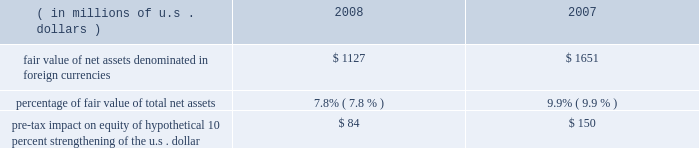Foreign currency exchange rate risk many of our non-u.s .
Companies maintain both assets and liabilities in local currencies .
Therefore , foreign exchange rate risk is generally limited to net assets denominated in those foreign currencies .
Foreign exchange rate risk is reviewed as part of our risk management process .
Locally required capital levels are invested in home currencies in order to satisfy regulatory require- ments and to support local insurance operations regardless of currency fluctuations .
The principal currencies creating foreign exchange risk for us are the british pound sterling , the euro , and the canadian dollar .
The table provides more information on our exposure to foreign exchange rate risk at december 31 , 2008 and 2007. .
Reinsurance of gmdb and gmib guarantees our net income is directly impacted by changes in the reserves calculated in connection with the reinsurance of variable annuity guarantees , primarily gmdb and gmib .
These reserves are calculated in accordance with sop 03-1 ( sop reserves ) and changes in these reserves are reflected as life and annuity benefit expense , which is included in life underwriting income .
In addition , our net income is directly impacted by the change in the fair value of the gmib liability ( fvl ) , which is classified as a derivative according to fas 133 .
The fair value liability established for a gmib reinsurance contract represents the differ- ence between the fair value of the contract and the sop 03-1 reserves .
Changes in the fair value of the gmib liability , net of associated changes in the calculated sop 03-1 reserve , are reflected as realized gains or losses .
Ace views our variable annuity reinsurance business as having a similar risk profile to that of catastrophe reinsurance , with the probability of long-term economic loss relatively small at the time of pricing .
Adverse changes in market factors and policyholder behavior will have an impact on both life underwriting income and net income .
When evaluating these risks , we expect to be compensated for taking both the risk of a cumulative long-term economic net loss , as well as the short-term accounting variations caused by these market movements .
Therefore , we evaluate this business in terms of its long-term eco- nomic risk and reward .
The ultimate risk to the variable annuity guaranty reinsurance business is a long-term underperformance of investment returns , which can be exacerbated by a long-term reduction in interest rates .
Following a market downturn , continued market underperformance over a period of five to seven years would eventually result in a higher level of paid claims as policyholders accessed their guarantees through death or annuitization .
However , if market conditions improved following a downturn , sop 03-1 reserves and fair value liability would fall reflecting a decreased likelihood of future claims , which would result in an increase in both life underwriting income and net income .
As of december 31 , 2008 , management established the sop 03-1 reserve based on the benefit ratio calculated using actual market values at december 31 , 2008 .
Management exercises judgment in determining the extent to which short-term market movements impact the sop 03-1 reserve .
The sop 03-1 reserve is based on the calculation of a long-term benefit ratio ( or loss ratio ) for the variable annuity guarantee reinsurance .
Despite the long-term nature of the risk the benefit ratio calculation is impacted by short-term market movements that may be judged by management to be temporary or transient .
Management will , in keeping with the language in sop 03-1 , regularly examine both quantitative and qualitative analysis and management will determine if , in its judgment , the change in the calculated benefit ratio is of sufficient magnitude and has persisted for a sufficient duration to warrant a change in the benefit ratio used to establish the sop 03-1 reserve .
This has no impact on either premium received or claims paid nor does it impact the long-term profit or loss of the variable annuity guaran- tee reinsurance .
The sop 03-1 reserve and fair value liability calculations are directly affected by market factors , including equity levels , interest rate levels , credit risk and implied volatilities , as well as policyholder behaviors , such as annuitization and lapse rates .
The table below shows the sensitivity , as of december 31 , 2008 , of the sop 03-1 reserves and fair value liability associated with the variable annuity guarantee reinsurance portfolio .
In addition , the tables below show the sensitivity of the fair value of specific derivative instruments held ( hedge value ) , which includes instruments purchased in january 2009 , to partially offset the risk in the variable annuity guarantee reinsurance portfolio .
Although these derivatives do not receive hedge accounting treatment , some portion of the change in value may be used to offset changes in the sop 03-1 reserve. .
What are the total net assets in 2008 , ( in millions ) ? 
Computations: (1127 / 7.8%)
Answer: 14448.71795. 